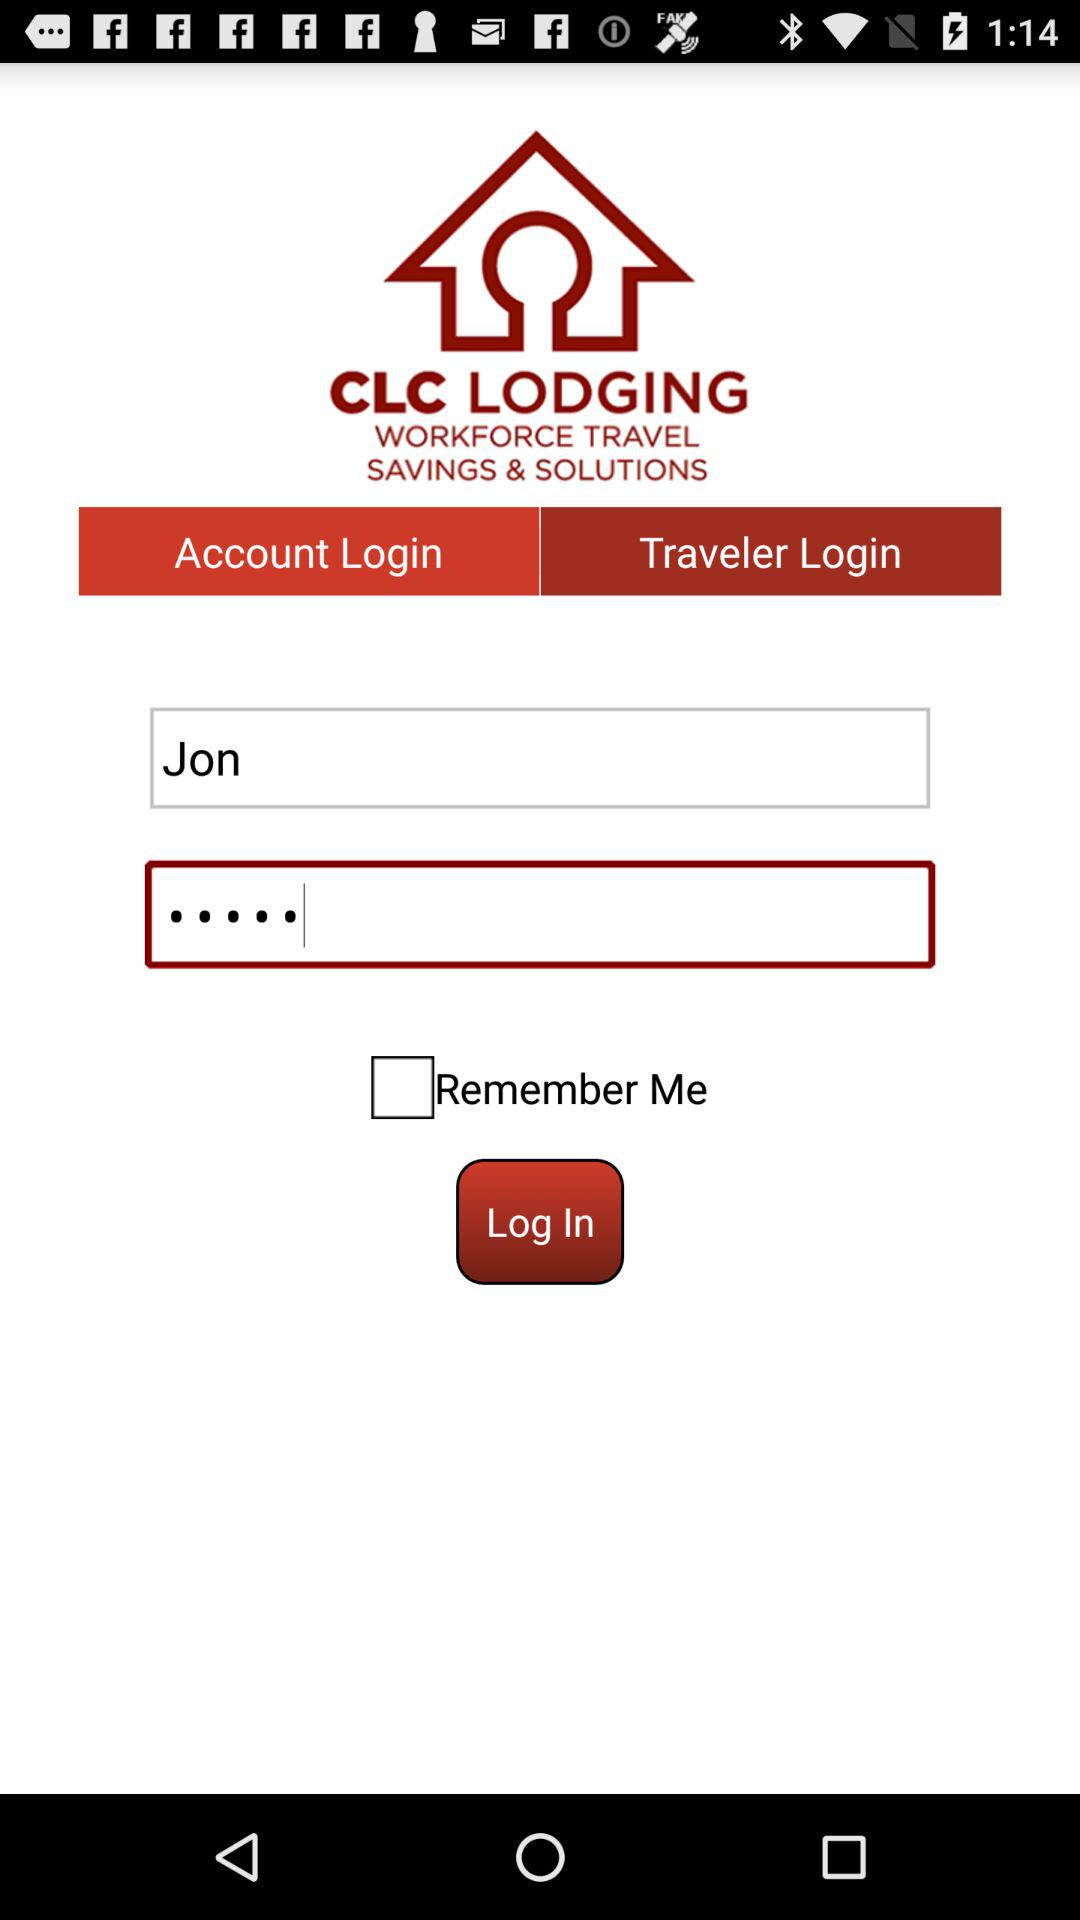Which tab is selected? The selected tab is "Account Login". 